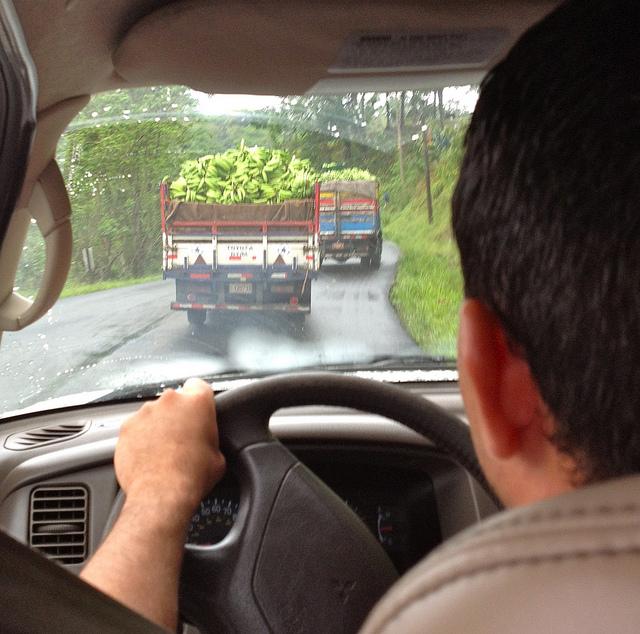Are there bananas in the back of that truck?
Give a very brief answer. Yes. What is the man holding?
Write a very short answer. Steering wheel. Is the man's ear pierced?
Give a very brief answer. No. 